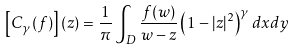<formula> <loc_0><loc_0><loc_500><loc_500>\left [ C _ { \gamma } ( f ) \right ] ( z ) & = \frac { 1 } { \pi } \int _ { D } \frac { f ( w ) } { w - z } \left ( 1 - | { z } | ^ { 2 } \right ) ^ { \gamma } d x d y</formula> 